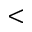<formula> <loc_0><loc_0><loc_500><loc_500><</formula> 